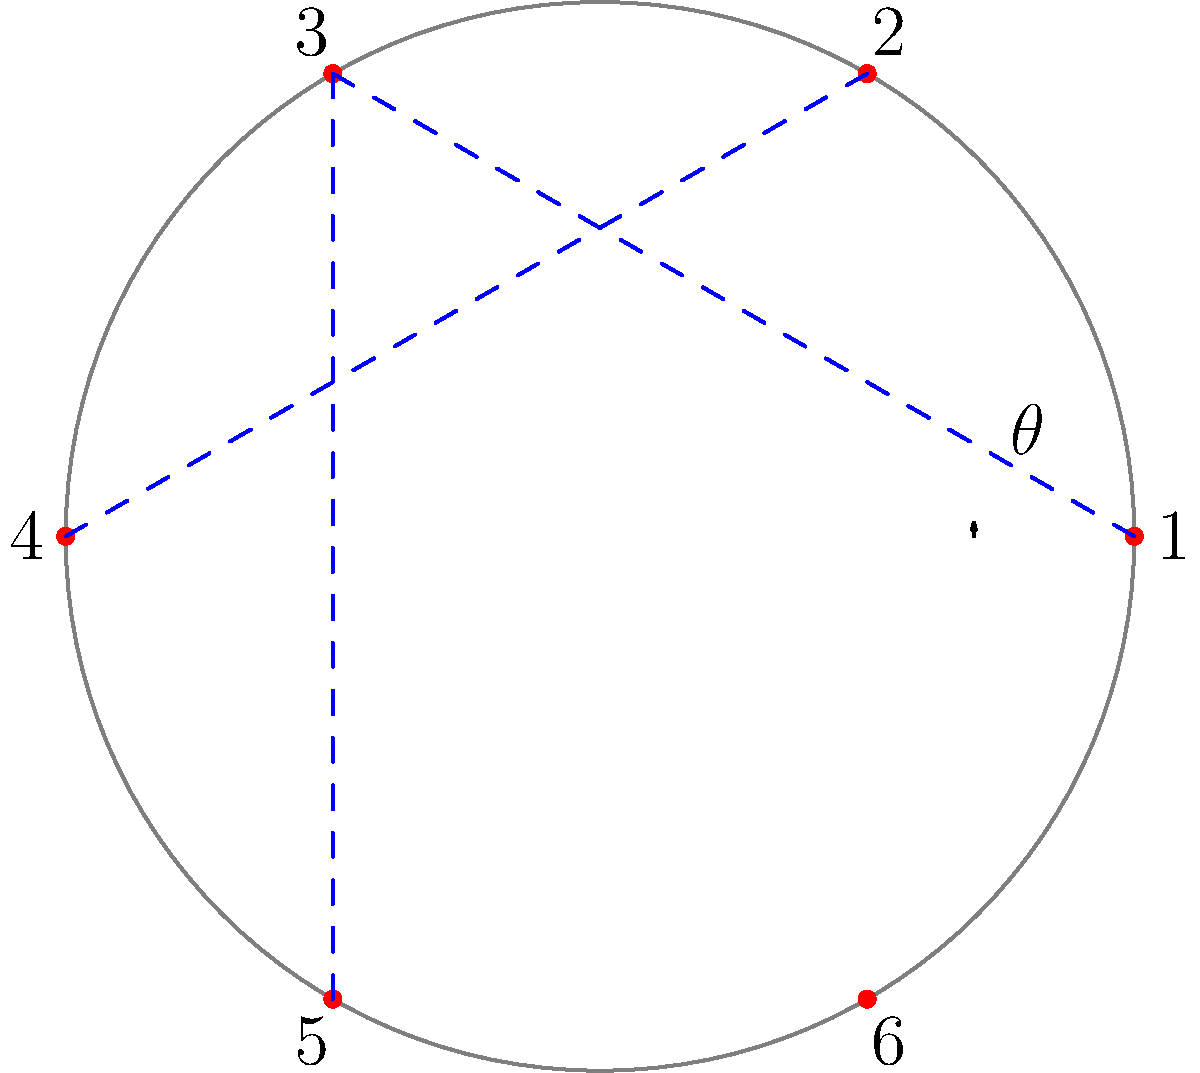In a blockchain network visualization using polar coordinates, six nodes are equally spaced around a circle of radius 5 units. If node 1 is at $(5, 0)$ and node 3 is connected to node 1, what is the Euclidean distance between these two nodes? Let's approach this step-by-step:

1) In polar coordinates, the six nodes are equally spaced around the circle. This means the angle between each node is $\frac{2\pi}{6} = \frac{\pi}{3}$ radians.

2) Node 1 is at $(5, 0)$ in polar coordinates, which is the same in Cartesian coordinates.

3) Node 3 is two positions away from Node 1, so its angle is $2 \cdot \frac{\pi}{3} = \frac{2\pi}{3}$ radians.

4) To find the Cartesian coordinates of Node 3, we use:
   $x = r \cos(\theta) = 5 \cos(\frac{2\pi}{3}) = 5 \cdot (-\frac{1}{2}) = -2.5$
   $y = r \sin(\theta) = 5 \sin(\frac{2\pi}{3}) = 5 \cdot \frac{\sqrt{3}}{2} = \frac{5\sqrt{3}}{2}$

5) Now we have two points:
   Node 1: $(5, 0)$
   Node 3: $(-2.5, \frac{5\sqrt{3}}{2})$

6) To find the Euclidean distance, we use the distance formula:
   $d = \sqrt{(x_2-x_1)^2 + (y_2-y_1)^2}$

7) Plugging in our values:
   $d = \sqrt{(-2.5-5)^2 + (\frac{5\sqrt{3}}{2}-0)^2}$

8) Simplify:
   $d = \sqrt{(-7.5)^2 + (\frac{5\sqrt{3}}{2})^2}$
   $= \sqrt{56.25 + \frac{75}{4}}$
   $= \sqrt{\frac{225}{4} + \frac{75}{4}}$
   $= \sqrt{\frac{300}{4}}$
   $= \sqrt{75}$
   $= 5\sqrt{3}$

Therefore, the Euclidean distance between Node 1 and Node 3 is $5\sqrt{3}$ units.
Answer: $5\sqrt{3}$ units 